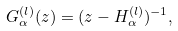Convert formula to latex. <formula><loc_0><loc_0><loc_500><loc_500>G _ { \alpha } ^ { ( l ) } ( z ) = ( z - H _ { \alpha } ^ { ( l ) } ) ^ { - 1 } ,</formula> 